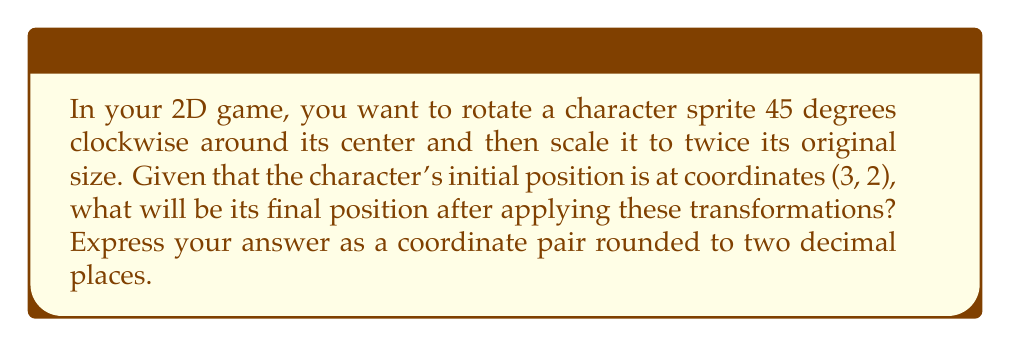What is the answer to this math problem? Let's approach this step-by-step:

1) First, we need to create the rotation matrix for 45 degrees clockwise. The general 2D rotation matrix is:

   $$R(\theta) = \begin{bmatrix} \cos\theta & -\sin\theta \\ \sin\theta & \cos\theta \end{bmatrix}$$

   For 45 degrees clockwise, $\theta = -45°$ or $-\pi/4$ radians. So:

   $$R(-45°) = \begin{bmatrix} \cos(-45°) & -\sin(-45°) \\ \sin(-45°) & \cos(-45°) \end{bmatrix} = \begin{bmatrix} \frac{\sqrt{2}}{2} & \frac{\sqrt{2}}{2} \\ -\frac{\sqrt{2}}{2} & \frac{\sqrt{2}}{2} \end{bmatrix}$$

2) Next, we need the scaling matrix to double the size:

   $$S = \begin{bmatrix} 2 & 0 \\ 0 & 2 \end{bmatrix}$$

3) We apply the rotation first, then the scaling. So our transformation matrix $T$ is:

   $$T = S \cdot R(-45°) = \begin{bmatrix} 2 & 0 \\ 0 & 2 \end{bmatrix} \cdot \begin{bmatrix} \frac{\sqrt{2}}{2} & \frac{\sqrt{2}}{2} \\ -\frac{\sqrt{2}}{2} & \frac{\sqrt{2}}{2} \end{bmatrix} = \begin{bmatrix} \sqrt{2} & \sqrt{2} \\ -\sqrt{2} & \sqrt{2} \end{bmatrix}$$

4) Now we apply this transformation to our initial position (3, 2):

   $$\begin{bmatrix} \sqrt{2} & \sqrt{2} \\ -\sqrt{2} & \sqrt{2} \end{bmatrix} \cdot \begin{bmatrix} 3 \\ 2 \end{bmatrix} = \begin{bmatrix} 3\sqrt{2} + 2\sqrt{2} \\ -3\sqrt{2} + 2\sqrt{2} \end{bmatrix} = \begin{bmatrix} 5\sqrt{2} \\ -\sqrt{2} \end{bmatrix}$$

5) Simplifying:
   $5\sqrt{2} \approx 7.07$
   $-\sqrt{2} \approx -1.41$

Therefore, the final position, rounded to two decimal places, is (7.07, -1.41).
Answer: (7.07, -1.41) 